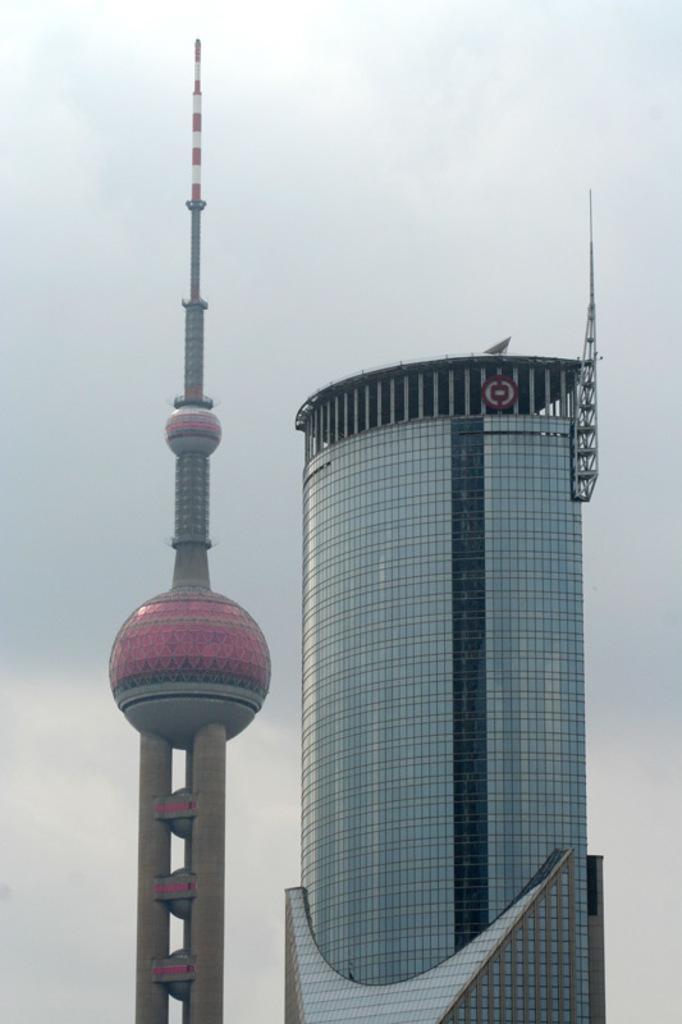In one or two sentences, can you explain what this image depicts? In this image we can see the glass building and also the tower. In the background there is a cloudy sky. 